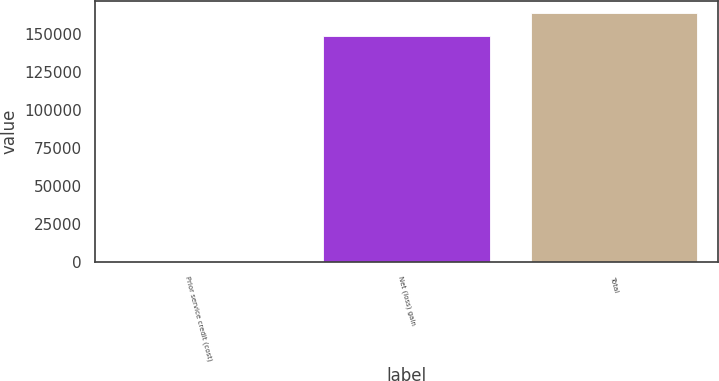Convert chart. <chart><loc_0><loc_0><loc_500><loc_500><bar_chart><fcel>Prior service credit (cost)<fcel>Net (loss) gain<fcel>Total<nl><fcel>275<fcel>148933<fcel>163826<nl></chart> 